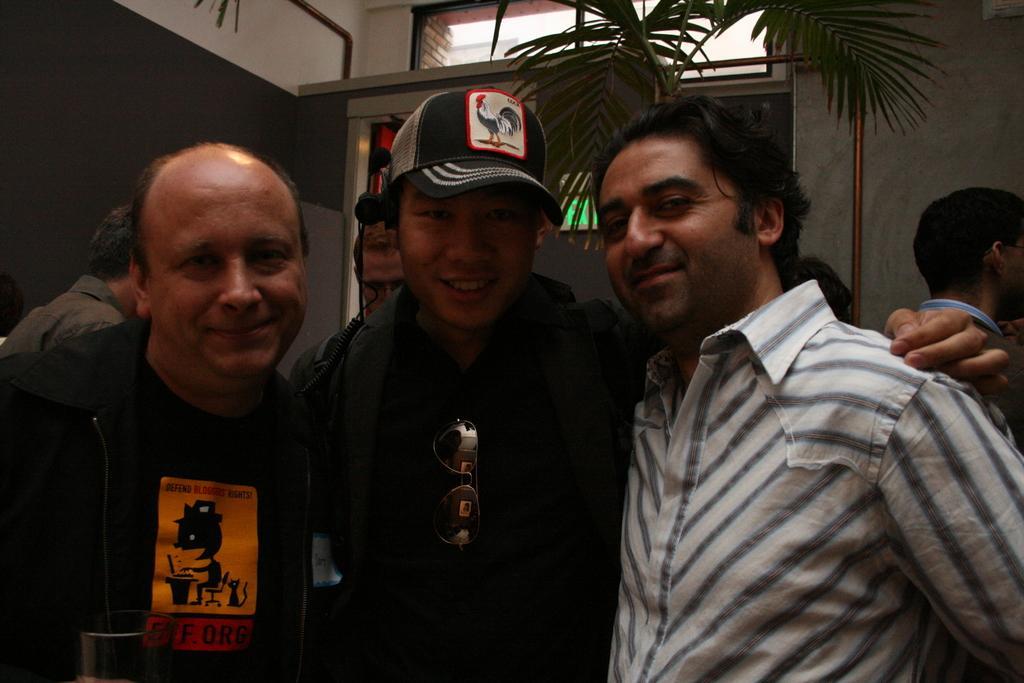Can you describe this image briefly? In this image I can see two persons wearing black colored dresses and another person wearing white colored dress are standing and I can see a person is holding a glass in his hands. In the background I can see few persons, a tree, the wall and a green colored board. 